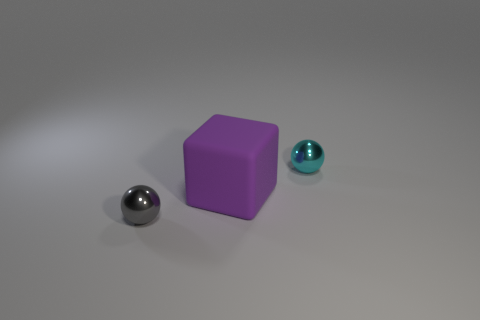Are there any other things that have the same size as the cyan sphere?
Ensure brevity in your answer.  Yes. What is the size of the other metal thing that is the same shape as the small cyan metallic object?
Your response must be concise. Small. Are there more big green spheres than cyan balls?
Your answer should be compact. No. What shape is the purple matte object in front of the tiny ball that is behind the purple matte cube?
Offer a very short reply. Cube. There is a metal object that is on the left side of the small sphere right of the tiny gray metal sphere; are there any gray objects behind it?
Give a very brief answer. No. There is a sphere that is the same size as the cyan object; what is its color?
Provide a short and direct response. Gray. The thing that is both on the left side of the cyan thing and on the right side of the gray thing has what shape?
Your answer should be compact. Cube. What is the size of the metal ball that is in front of the small ball right of the big rubber thing?
Provide a succinct answer. Small. How many small metallic objects are the same color as the big matte cube?
Ensure brevity in your answer.  0. What number of other things are the same size as the matte cube?
Ensure brevity in your answer.  0. 